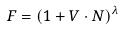Convert formula to latex. <formula><loc_0><loc_0><loc_500><loc_500>F = ( 1 + V \cdot N ) ^ { \lambda }</formula> 